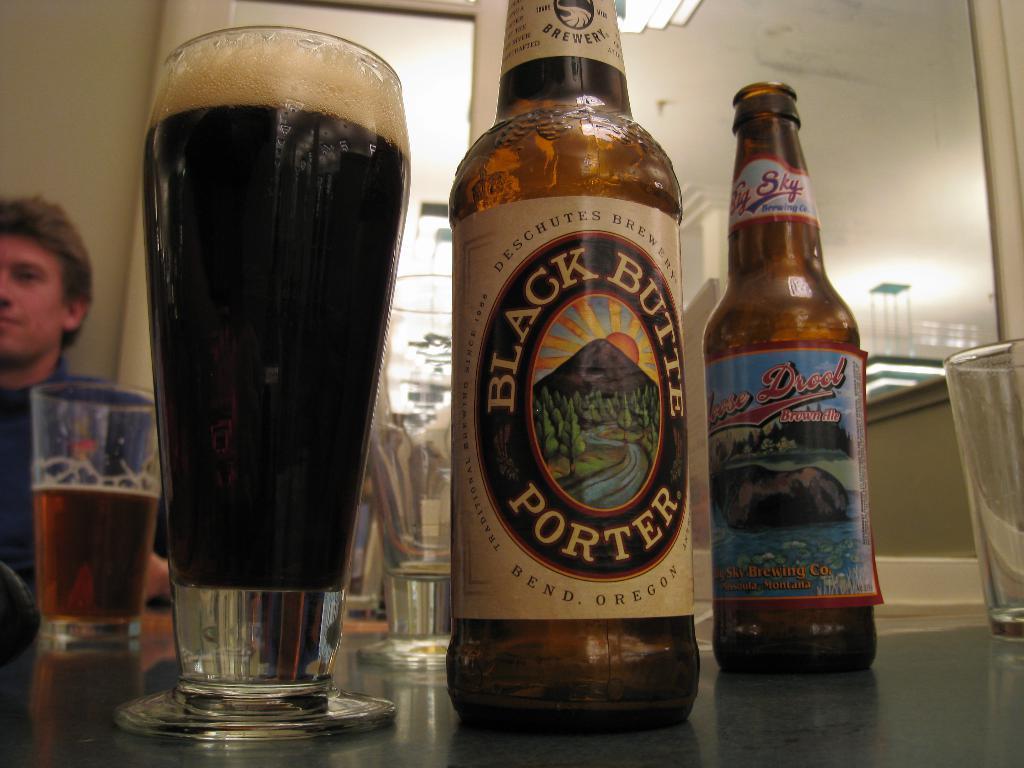How would you summarize this image in a sentence or two? In this image I can see two bottles and some glasses with liquid. On the left side of the image I can see a person sitting. 